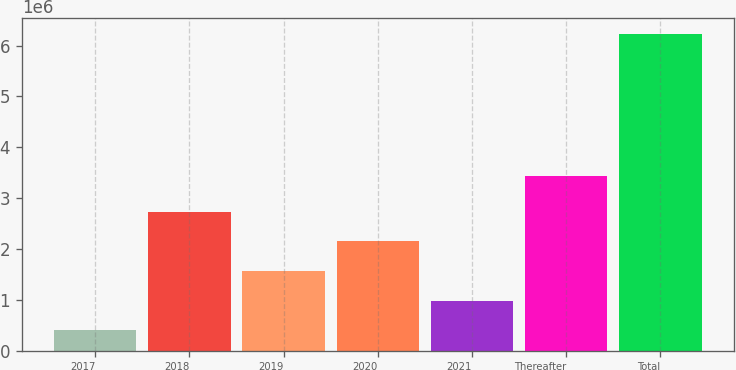<chart> <loc_0><loc_0><loc_500><loc_500><bar_chart><fcel>2017<fcel>2018<fcel>2019<fcel>2020<fcel>2021<fcel>Thereafter<fcel>Total<nl><fcel>401595<fcel>2.73415e+06<fcel>1.56787e+06<fcel>2.15101e+06<fcel>984734<fcel>3.43e+06<fcel>6.23299e+06<nl></chart> 